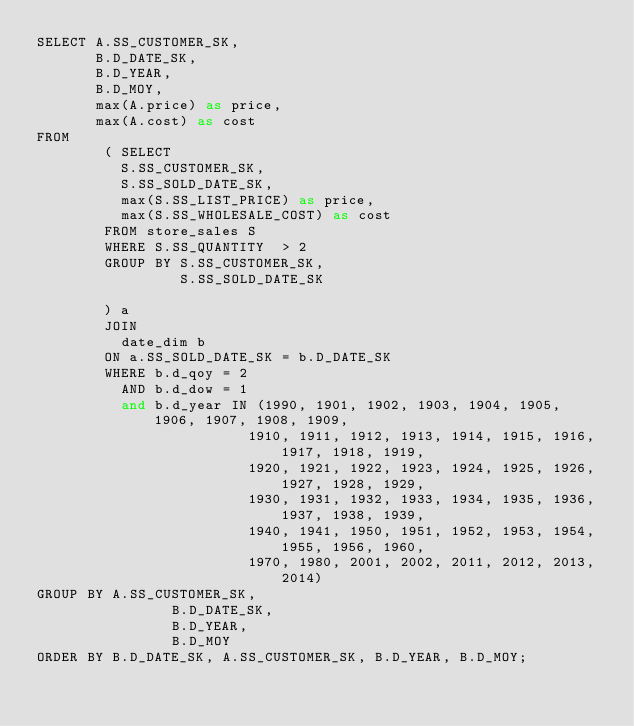<code> <loc_0><loc_0><loc_500><loc_500><_SQL_>SELECT A.SS_CUSTOMER_SK,
       B.D_DATE_SK,
       B.D_YEAR,
       B.D_MOY,
       max(A.price) as price,
       max(A.cost) as cost
FROM
        ( SELECT
          S.SS_CUSTOMER_SK,
          S.SS_SOLD_DATE_SK,
          max(S.SS_LIST_PRICE) as price,
          max(S.SS_WHOLESALE_COST) as cost
        FROM store_sales S
        WHERE S.SS_QUANTITY  > 2
        GROUP BY S.SS_CUSTOMER_SK,
                 S.SS_SOLD_DATE_SK

        ) a
        JOIN
          date_dim b
        ON a.SS_SOLD_DATE_SK = b.D_DATE_SK
        WHERE b.d_qoy = 2
          AND b.d_dow = 1
          and b.d_year IN (1990, 1901, 1902, 1903, 1904, 1905, 1906, 1907, 1908, 1909,
                         1910, 1911, 1912, 1913, 1914, 1915, 1916, 1917, 1918, 1919,
                         1920, 1921, 1922, 1923, 1924, 1925, 1926, 1927, 1928, 1929,
                         1930, 1931, 1932, 1933, 1934, 1935, 1936, 1937, 1938, 1939,
                         1940, 1941, 1950, 1951, 1952, 1953, 1954, 1955, 1956, 1960,
                         1970, 1980, 2001, 2002, 2011, 2012, 2013, 2014)
GROUP BY A.SS_CUSTOMER_SK,
                B.D_DATE_SK,
                B.D_YEAR,
                B.D_MOY
ORDER BY B.D_DATE_SK, A.SS_CUSTOMER_SK, B.D_YEAR, B.D_MOY;
</code> 